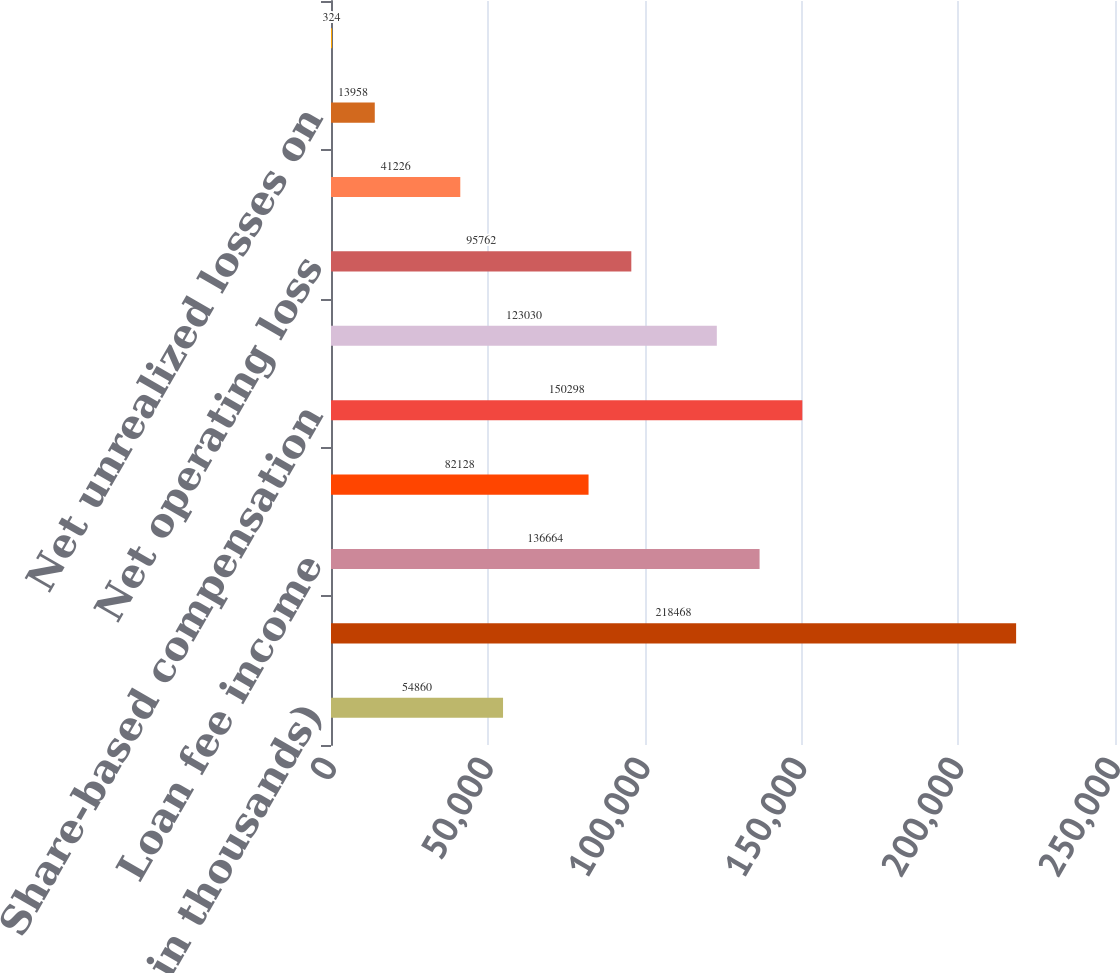Convert chart to OTSL. <chart><loc_0><loc_0><loc_500><loc_500><bar_chart><fcel>(Dollars in thousands)<fcel>Allowance for loan losses<fcel>Loan fee income<fcel>Other accruals not currently<fcel>Share-based compensation<fcel>State income taxes<fcel>Net operating loss<fcel>Premises and equipment and<fcel>Net unrealized losses on<fcel>Research and development<nl><fcel>54860<fcel>218468<fcel>136664<fcel>82128<fcel>150298<fcel>123030<fcel>95762<fcel>41226<fcel>13958<fcel>324<nl></chart> 